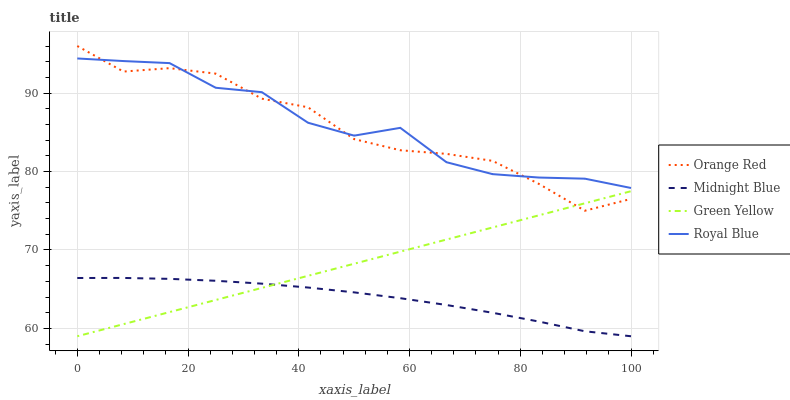Does Midnight Blue have the minimum area under the curve?
Answer yes or no. Yes. Does Royal Blue have the maximum area under the curve?
Answer yes or no. Yes. Does Green Yellow have the minimum area under the curve?
Answer yes or no. No. Does Green Yellow have the maximum area under the curve?
Answer yes or no. No. Is Green Yellow the smoothest?
Answer yes or no. Yes. Is Royal Blue the roughest?
Answer yes or no. Yes. Is Orange Red the smoothest?
Answer yes or no. No. Is Orange Red the roughest?
Answer yes or no. No. Does Green Yellow have the lowest value?
Answer yes or no. Yes. Does Orange Red have the lowest value?
Answer yes or no. No. Does Orange Red have the highest value?
Answer yes or no. Yes. Does Green Yellow have the highest value?
Answer yes or no. No. Is Green Yellow less than Royal Blue?
Answer yes or no. Yes. Is Royal Blue greater than Green Yellow?
Answer yes or no. Yes. Does Green Yellow intersect Orange Red?
Answer yes or no. Yes. Is Green Yellow less than Orange Red?
Answer yes or no. No. Is Green Yellow greater than Orange Red?
Answer yes or no. No. Does Green Yellow intersect Royal Blue?
Answer yes or no. No. 